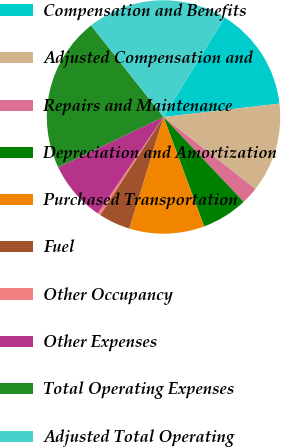<chart> <loc_0><loc_0><loc_500><loc_500><pie_chart><fcel>Compensation and Benefits<fcel>Adjusted Compensation and<fcel>Repairs and Maintenance<fcel>Depreciation and Amortization<fcel>Purchased Transportation<fcel>Fuel<fcel>Other Occupancy<fcel>Other Expenses<fcel>Total Operating Expenses<fcel>Adjusted Total Operating<nl><fcel>14.4%<fcel>12.4%<fcel>2.38%<fcel>6.39%<fcel>10.4%<fcel>4.39%<fcel>0.38%<fcel>8.39%<fcel>21.44%<fcel>19.43%<nl></chart> 